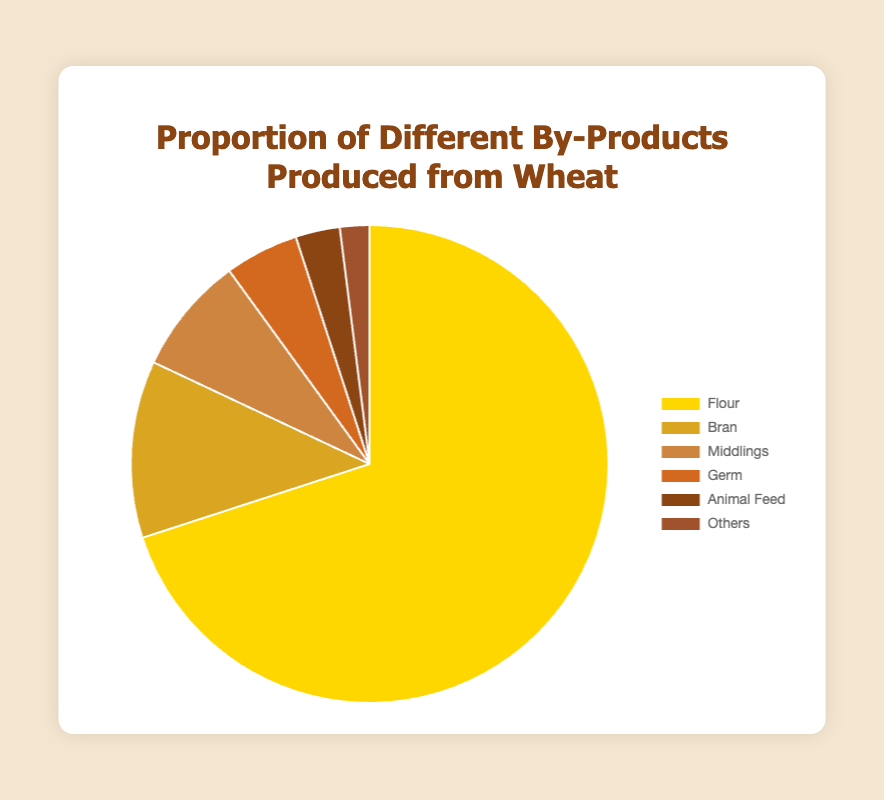Which by-product has the highest proportion? The by-product with the highest proportion can be identified by looking at the largest section of the pie chart and its labeling. The largest section is labeled "Flour" which has a proportion of 70%.
Answer: Flour What is the combined proportion of Bran and Germ? To find the combined proportion, sum the proportions of Bran and Germ. The proportion of Bran is 12%, and the proportion of Germ is 5%, so the combined proportion is 12% + 5% = 17%.
Answer: 17% How does the proportion of Middlings compare to Animal Feed? Compare the sections of Middlings and Animal Feed. Middlings has a proportion of 8% while Animal Feed has 3%, so Middlings is greater than Animal Feed by 8% - 3% = 5%.
Answer: Middlings has a higher proportion by 5% What proportion of the by-products is accounted for by "Others"? Look at the section labeled "Others" in the pie chart. The proportion for "Others" is given as 2%.
Answer: 2% Which two by-products together make up exactly 20%? Add proportions of different combinations to find which sums to 20%. Germ (5%) + Middlings (8%) + Animal Feed (3%) + Others (2%) = 18%. However, Bran (12%) + Germ (5%) + Animal Feed (3%) = 20%.
Answer: Bran and Animal Feed Is the proportion of "Bran" more than double that of "Animal Feed"? Double the proportion of Animal Feed (3%) to determine if Bran exceeds this. 3% × 2 = 6%, and Bran has 12%, which is more than double 6%.
Answer: Yes Which by-product has the smallest proportion, and what is it? Find the smallest section in the pie chart, which is labeled "Others" and has a proportion of 2%.
Answer: Others with 2% What percentage of the total is made up by by-products other than flour? Subtract the proportion of Flour from 100% to find the remaining by-products’ total. 100% - 70% = 30%.
Answer: 30% What is the difference in proportion between the by-products with the largest and smallest sections? The largest section "Flour" has 70%, and the smallest "Others" has 2%. The difference is 70% - 2% = 68%.
Answer: 68% Which by-product has a brown color and what is its proportion? Identify the section with a brown color and its corresponding label. "Animal Feed" is represented with a brown color and has a proportion of 3%.
Answer: Animal Feed, 3% 